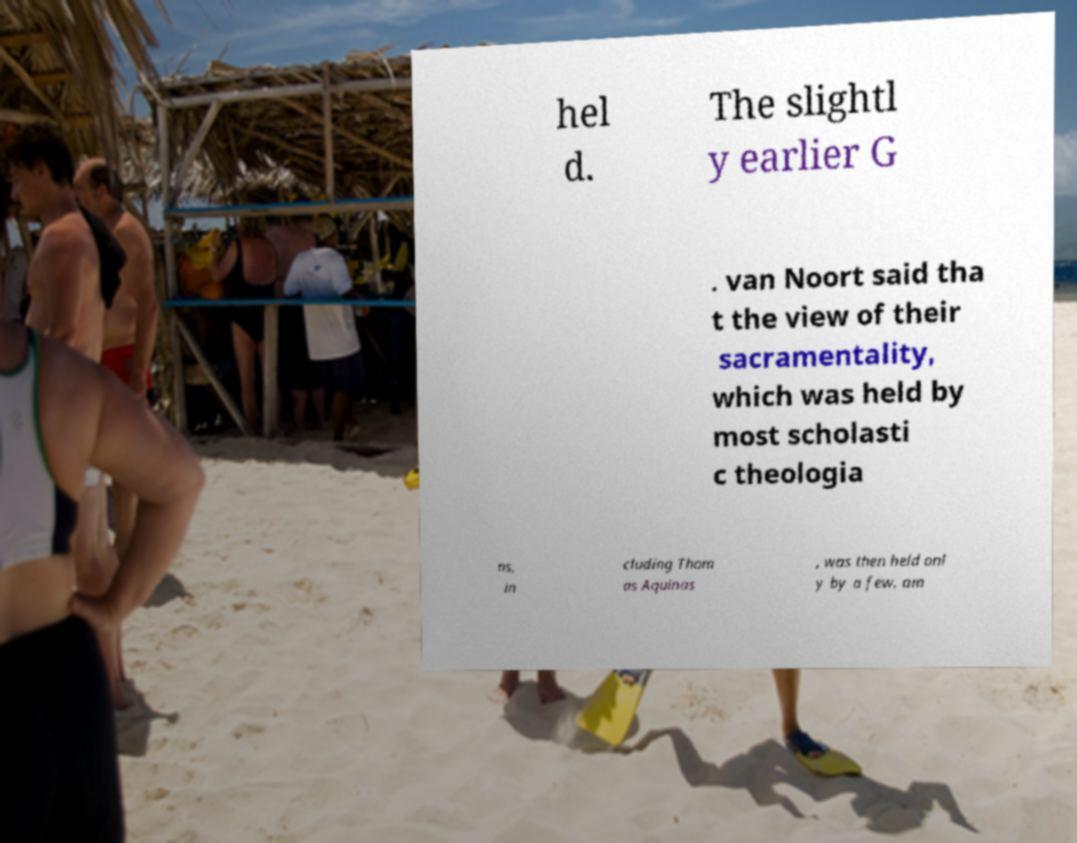For documentation purposes, I need the text within this image transcribed. Could you provide that? hel d. The slightl y earlier G . van Noort said tha t the view of their sacramentality, which was held by most scholasti c theologia ns, in cluding Thom as Aquinas , was then held onl y by a few, am 